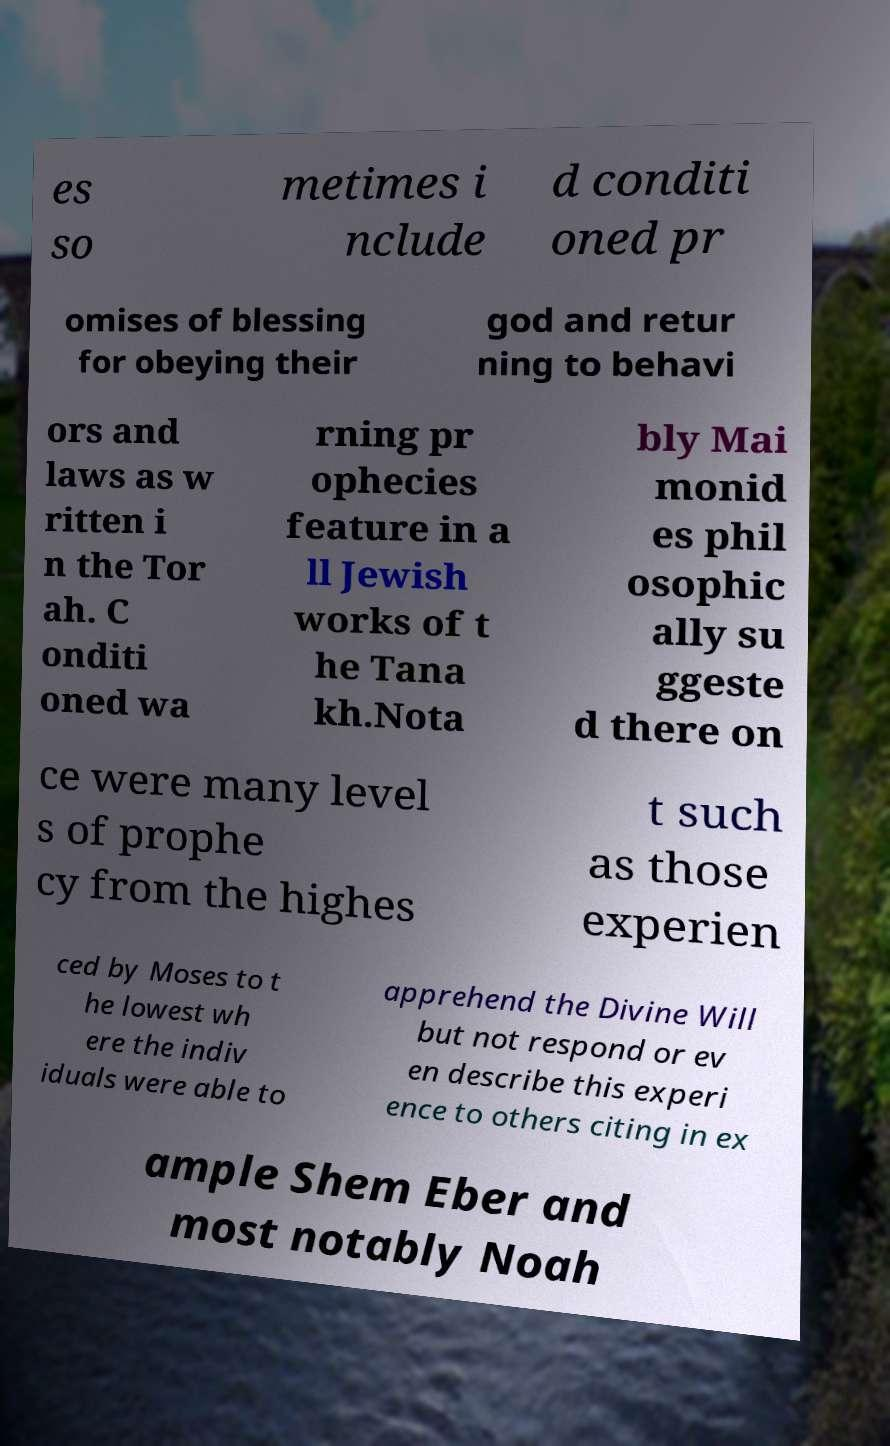I need the written content from this picture converted into text. Can you do that? es so metimes i nclude d conditi oned pr omises of blessing for obeying their god and retur ning to behavi ors and laws as w ritten i n the Tor ah. C onditi oned wa rning pr ophecies feature in a ll Jewish works of t he Tana kh.Nota bly Mai monid es phil osophic ally su ggeste d there on ce were many level s of prophe cy from the highes t such as those experien ced by Moses to t he lowest wh ere the indiv iduals were able to apprehend the Divine Will but not respond or ev en describe this experi ence to others citing in ex ample Shem Eber and most notably Noah 